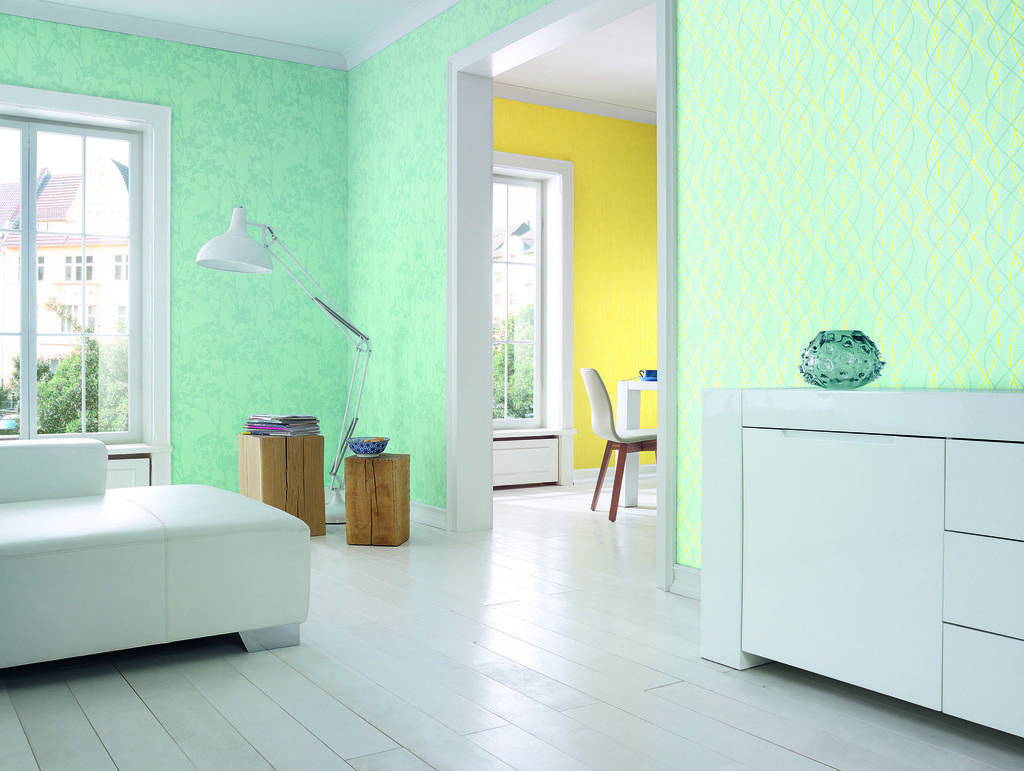Please provide a concise description of this image. This picture shows an inner view of the house I can see e couple of tables and chairs and a stand light and few books on another table and a bowl on the small table and a sofa bed and couple of glass windows from the glass, I can see buildings and trees and I can see a glass bowl on the right side table. 